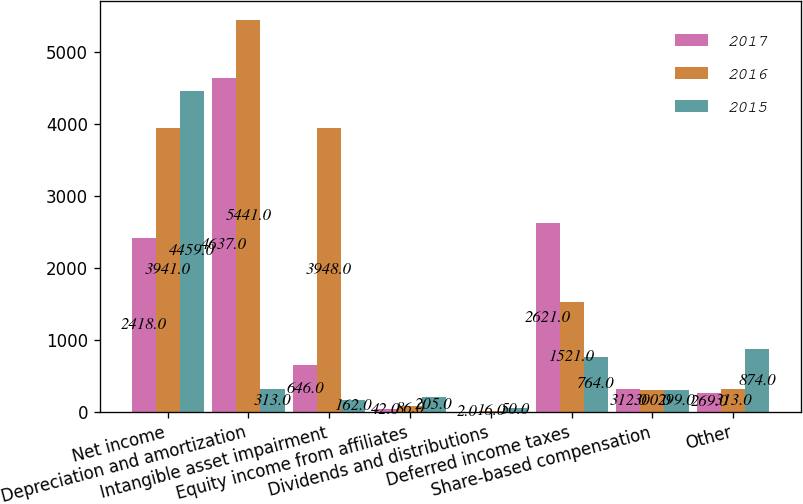Convert chart to OTSL. <chart><loc_0><loc_0><loc_500><loc_500><stacked_bar_chart><ecel><fcel>Net income<fcel>Depreciation and amortization<fcel>Intangible asset impairment<fcel>Equity income from affiliates<fcel>Dividends and distributions<fcel>Deferred income taxes<fcel>Share-based compensation<fcel>Other<nl><fcel>2017<fcel>2418<fcel>4637<fcel>646<fcel>42<fcel>2<fcel>2621<fcel>312<fcel>269<nl><fcel>2016<fcel>3941<fcel>5441<fcel>3948<fcel>86<fcel>16<fcel>1521<fcel>300<fcel>313<nl><fcel>2015<fcel>4459<fcel>313<fcel>162<fcel>205<fcel>50<fcel>764<fcel>299<fcel>874<nl></chart> 